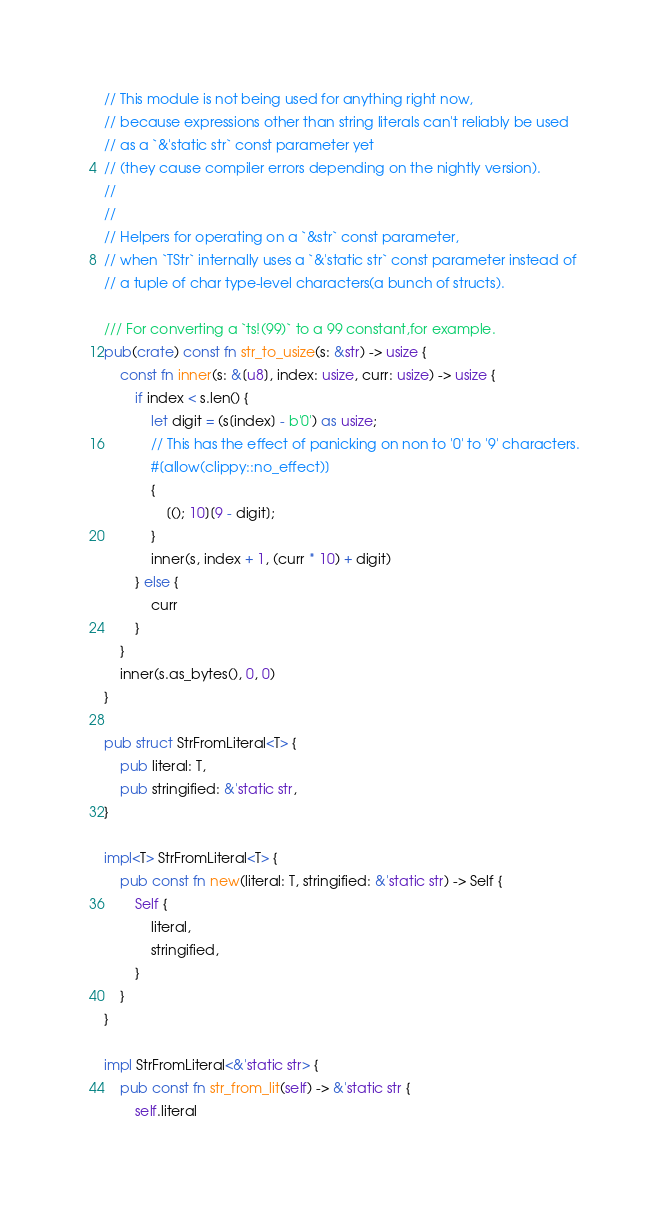<code> <loc_0><loc_0><loc_500><loc_500><_Rust_>// This module is not being used for anything right now,
// because expressions other than string literals can't reliably be used
// as a `&'static str` const parameter yet
// (they cause compiler errors depending on the nightly version).
//
//
// Helpers for operating on a `&str` const parameter,
// when `TStr` internally uses a `&'static str` const parameter instead of
// a tuple of char type-level characters(a bunch of structs).

/// For converting a `ts!(99)` to a 99 constant,for example.
pub(crate) const fn str_to_usize(s: &str) -> usize {
    const fn inner(s: &[u8], index: usize, curr: usize) -> usize {
        if index < s.len() {
            let digit = (s[index] - b'0') as usize;
            // This has the effect of panicking on non to '0' to '9' characters.
            #[allow(clippy::no_effect)]
            {
                [(); 10][9 - digit];
            }
            inner(s, index + 1, (curr * 10) + digit)
        } else {
            curr
        }
    }
    inner(s.as_bytes(), 0, 0)
}

pub struct StrFromLiteral<T> {
    pub literal: T,
    pub stringified: &'static str,
}

impl<T> StrFromLiteral<T> {
    pub const fn new(literal: T, stringified: &'static str) -> Self {
        Self {
            literal,
            stringified,
        }
    }
}

impl StrFromLiteral<&'static str> {
    pub const fn str_from_lit(self) -> &'static str {
        self.literal</code> 